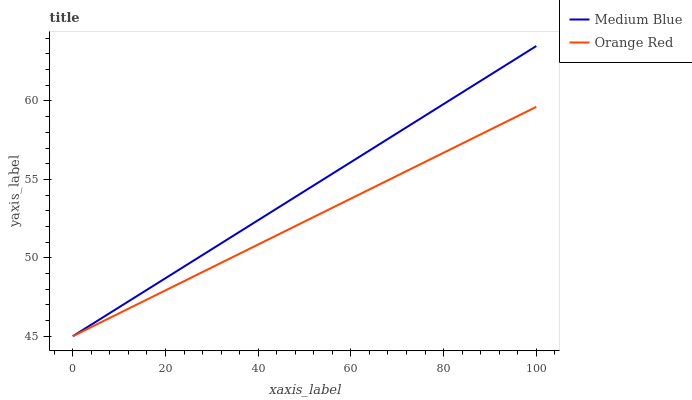Does Orange Red have the maximum area under the curve?
Answer yes or no. No. Is Orange Red the roughest?
Answer yes or no. No. Does Orange Red have the highest value?
Answer yes or no. No. 